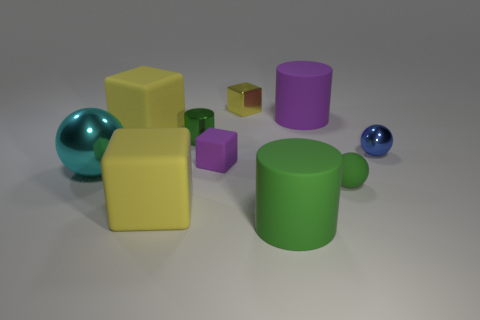What is the size of the green cylinder that is made of the same material as the purple cylinder?
Your answer should be very brief. Large. What shape is the big yellow object that is behind the green object that is on the left side of the purple thing on the left side of the purple cylinder?
Ensure brevity in your answer.  Cube. What is the size of the other metal object that is the same shape as the cyan metal object?
Your answer should be very brief. Small. There is a yellow object that is behind the big cyan shiny thing and on the left side of the small yellow metallic block; how big is it?
Provide a succinct answer. Large. There is a big object that is the same color as the metal cylinder; what is its shape?
Provide a succinct answer. Cylinder. The tiny metal cube is what color?
Your response must be concise. Yellow. There is a green metal cylinder that is to the left of the purple cylinder; what is its size?
Provide a succinct answer. Small. There is a tiny purple thing behind the large yellow thing in front of the cyan thing; how many big yellow rubber cubes are in front of it?
Your answer should be compact. 1. What is the color of the shiny object that is left of the big yellow object that is in front of the purple block?
Offer a very short reply. Cyan. Is there a blue shiny thing that has the same size as the metal cylinder?
Your response must be concise. Yes. 